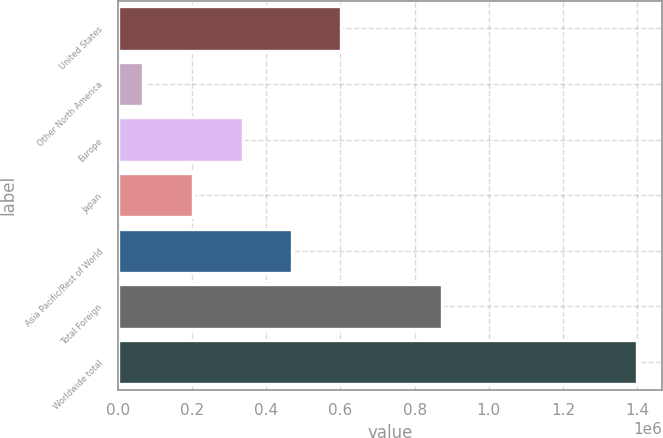<chart> <loc_0><loc_0><loc_500><loc_500><bar_chart><fcel>United States<fcel>Other North America<fcel>Europe<fcel>Japan<fcel>Asia Pacific/Rest of World<fcel>Total Foreign<fcel>Worldwide total<nl><fcel>602849<fcel>67189<fcel>336718<fcel>203652<fcel>469783<fcel>872534<fcel>1.39785e+06<nl></chart> 